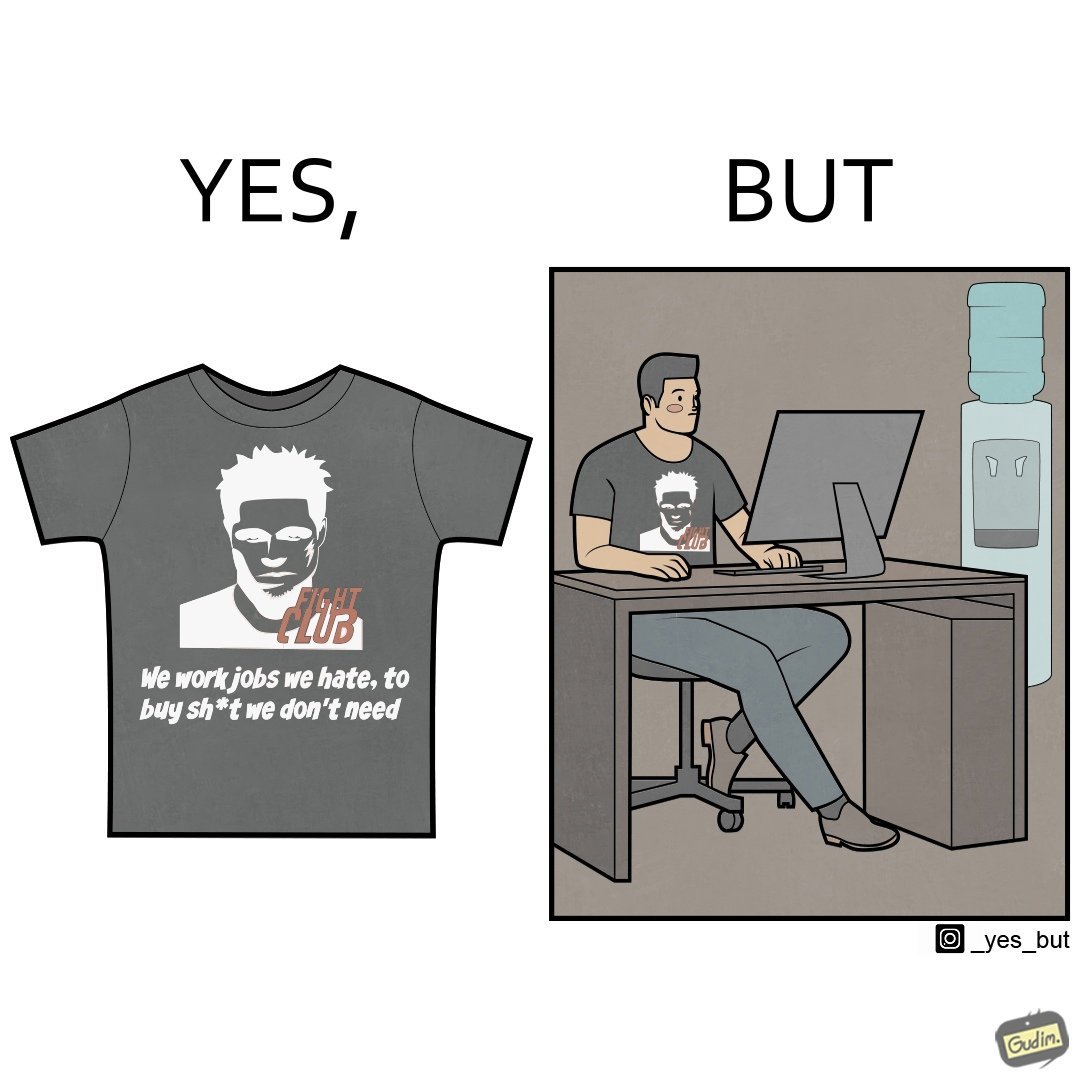Describe what you see in this image. The image is ironical, as the t-shirt says "We work jobs we hate, to buy sh*t we don't need", which is a rebellious message against the construct of office jobs. However, the person wearing the t-shirt seems to be working in an office environment. Also, the t-shirt might have been bought using the money earned via the very same job. 